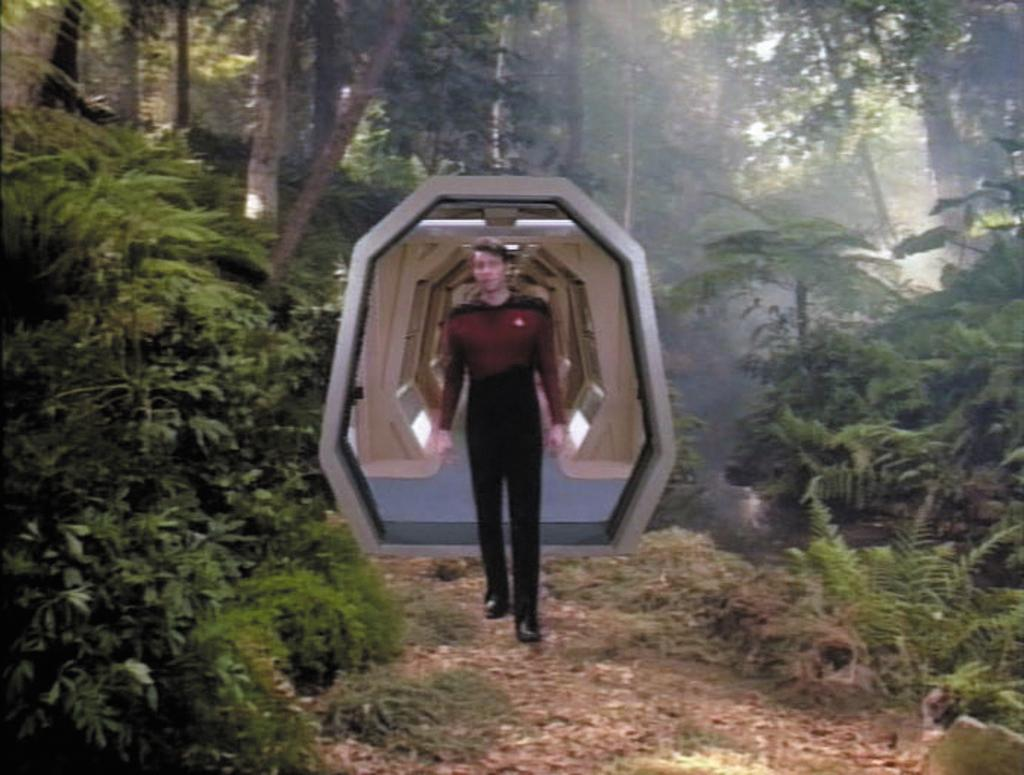What is the main subject of the image? There is a man standing in the image. Where is the man standing? The man is standing on the ground. What is located behind the man? There is a door behind the man. What can be seen on the ground on either side of the image? There are plants on the ground on either side of the image. What is visible in the background of the image? There are trees visible in the background of the image. What type of trousers is the zebra wearing in the image? There is no zebra present in the image, and therefore no trousers or any other clothing can be observed. What is the man doing in the image to prepare for war? There is no indication of war or any military activity in the image; the man is simply standing. 